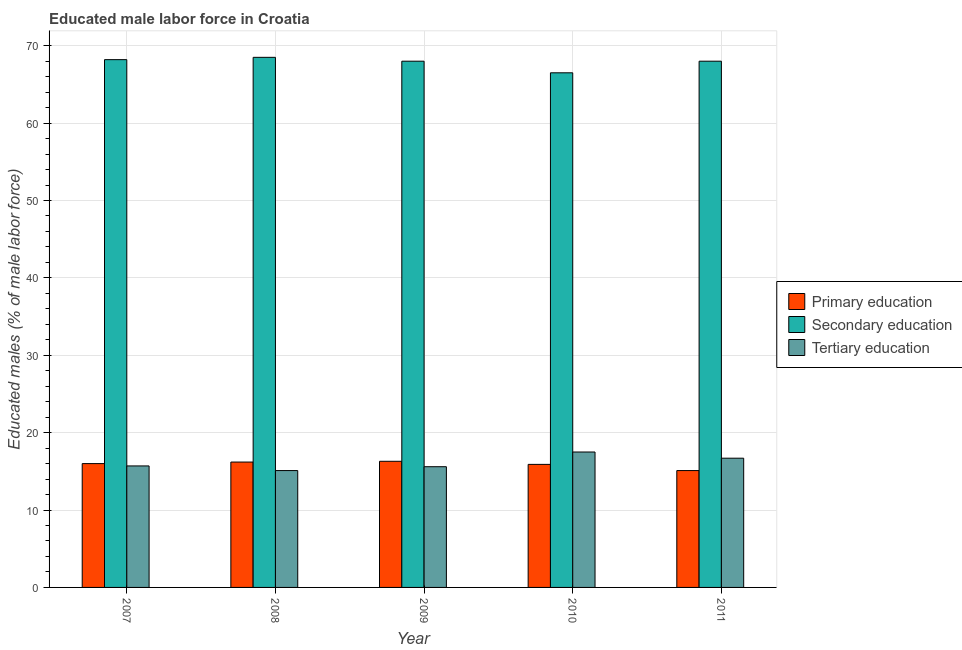How many groups of bars are there?
Offer a very short reply. 5. Are the number of bars on each tick of the X-axis equal?
Offer a terse response. Yes. What is the label of the 3rd group of bars from the left?
Offer a very short reply. 2009. What is the percentage of male labor force who received secondary education in 2007?
Make the answer very short. 68.2. Across all years, what is the maximum percentage of male labor force who received primary education?
Your response must be concise. 16.3. Across all years, what is the minimum percentage of male labor force who received primary education?
Your answer should be very brief. 15.1. In which year was the percentage of male labor force who received primary education minimum?
Keep it short and to the point. 2011. What is the total percentage of male labor force who received primary education in the graph?
Your response must be concise. 79.5. What is the difference between the percentage of male labor force who received tertiary education in 2008 and that in 2011?
Offer a very short reply. -1.6. What is the difference between the percentage of male labor force who received primary education in 2007 and the percentage of male labor force who received tertiary education in 2010?
Provide a succinct answer. 0.1. What is the average percentage of male labor force who received tertiary education per year?
Keep it short and to the point. 16.12. What is the ratio of the percentage of male labor force who received primary education in 2007 to that in 2008?
Provide a short and direct response. 0.99. What is the difference between the highest and the second highest percentage of male labor force who received tertiary education?
Keep it short and to the point. 0.8. What is the difference between the highest and the lowest percentage of male labor force who received secondary education?
Offer a very short reply. 2. Is the sum of the percentage of male labor force who received tertiary education in 2009 and 2011 greater than the maximum percentage of male labor force who received secondary education across all years?
Your answer should be very brief. Yes. What does the 2nd bar from the left in 2009 represents?
Provide a short and direct response. Secondary education. Is it the case that in every year, the sum of the percentage of male labor force who received primary education and percentage of male labor force who received secondary education is greater than the percentage of male labor force who received tertiary education?
Provide a short and direct response. Yes. How many bars are there?
Offer a very short reply. 15. Are all the bars in the graph horizontal?
Offer a very short reply. No. What is the difference between two consecutive major ticks on the Y-axis?
Keep it short and to the point. 10. Does the graph contain any zero values?
Your response must be concise. No. Where does the legend appear in the graph?
Your answer should be compact. Center right. How many legend labels are there?
Provide a short and direct response. 3. How are the legend labels stacked?
Provide a short and direct response. Vertical. What is the title of the graph?
Provide a short and direct response. Educated male labor force in Croatia. What is the label or title of the X-axis?
Ensure brevity in your answer.  Year. What is the label or title of the Y-axis?
Your response must be concise. Educated males (% of male labor force). What is the Educated males (% of male labor force) in Secondary education in 2007?
Your answer should be very brief. 68.2. What is the Educated males (% of male labor force) of Tertiary education in 2007?
Your response must be concise. 15.7. What is the Educated males (% of male labor force) in Primary education in 2008?
Offer a terse response. 16.2. What is the Educated males (% of male labor force) of Secondary education in 2008?
Offer a terse response. 68.5. What is the Educated males (% of male labor force) of Tertiary education in 2008?
Your answer should be compact. 15.1. What is the Educated males (% of male labor force) in Primary education in 2009?
Make the answer very short. 16.3. What is the Educated males (% of male labor force) in Tertiary education in 2009?
Ensure brevity in your answer.  15.6. What is the Educated males (% of male labor force) in Primary education in 2010?
Your response must be concise. 15.9. What is the Educated males (% of male labor force) of Secondary education in 2010?
Your response must be concise. 66.5. What is the Educated males (% of male labor force) in Tertiary education in 2010?
Your answer should be compact. 17.5. What is the Educated males (% of male labor force) in Primary education in 2011?
Offer a terse response. 15.1. What is the Educated males (% of male labor force) of Secondary education in 2011?
Offer a terse response. 68. What is the Educated males (% of male labor force) of Tertiary education in 2011?
Keep it short and to the point. 16.7. Across all years, what is the maximum Educated males (% of male labor force) in Primary education?
Offer a terse response. 16.3. Across all years, what is the maximum Educated males (% of male labor force) in Secondary education?
Provide a short and direct response. 68.5. Across all years, what is the minimum Educated males (% of male labor force) of Primary education?
Give a very brief answer. 15.1. Across all years, what is the minimum Educated males (% of male labor force) in Secondary education?
Your response must be concise. 66.5. Across all years, what is the minimum Educated males (% of male labor force) in Tertiary education?
Keep it short and to the point. 15.1. What is the total Educated males (% of male labor force) of Primary education in the graph?
Provide a short and direct response. 79.5. What is the total Educated males (% of male labor force) in Secondary education in the graph?
Give a very brief answer. 339.2. What is the total Educated males (% of male labor force) of Tertiary education in the graph?
Offer a terse response. 80.6. What is the difference between the Educated males (% of male labor force) in Secondary education in 2007 and that in 2008?
Ensure brevity in your answer.  -0.3. What is the difference between the Educated males (% of male labor force) in Primary education in 2007 and that in 2009?
Your response must be concise. -0.3. What is the difference between the Educated males (% of male labor force) in Secondary education in 2007 and that in 2009?
Keep it short and to the point. 0.2. What is the difference between the Educated males (% of male labor force) of Tertiary education in 2007 and that in 2009?
Provide a short and direct response. 0.1. What is the difference between the Educated males (% of male labor force) in Primary education in 2007 and that in 2010?
Your answer should be very brief. 0.1. What is the difference between the Educated males (% of male labor force) in Primary education in 2007 and that in 2011?
Make the answer very short. 0.9. What is the difference between the Educated males (% of male labor force) in Secondary education in 2008 and that in 2009?
Your answer should be very brief. 0.5. What is the difference between the Educated males (% of male labor force) of Primary education in 2008 and that in 2010?
Ensure brevity in your answer.  0.3. What is the difference between the Educated males (% of male labor force) of Secondary education in 2008 and that in 2010?
Your response must be concise. 2. What is the difference between the Educated males (% of male labor force) of Tertiary education in 2008 and that in 2010?
Your answer should be compact. -2.4. What is the difference between the Educated males (% of male labor force) of Primary education in 2008 and that in 2011?
Offer a very short reply. 1.1. What is the difference between the Educated males (% of male labor force) in Secondary education in 2009 and that in 2010?
Ensure brevity in your answer.  1.5. What is the difference between the Educated males (% of male labor force) in Secondary education in 2009 and that in 2011?
Your answer should be very brief. 0. What is the difference between the Educated males (% of male labor force) of Primary education in 2010 and that in 2011?
Provide a succinct answer. 0.8. What is the difference between the Educated males (% of male labor force) of Secondary education in 2010 and that in 2011?
Offer a terse response. -1.5. What is the difference between the Educated males (% of male labor force) in Primary education in 2007 and the Educated males (% of male labor force) in Secondary education in 2008?
Provide a short and direct response. -52.5. What is the difference between the Educated males (% of male labor force) in Secondary education in 2007 and the Educated males (% of male labor force) in Tertiary education in 2008?
Offer a very short reply. 53.1. What is the difference between the Educated males (% of male labor force) of Primary education in 2007 and the Educated males (% of male labor force) of Secondary education in 2009?
Your answer should be compact. -52. What is the difference between the Educated males (% of male labor force) in Secondary education in 2007 and the Educated males (% of male labor force) in Tertiary education in 2009?
Provide a short and direct response. 52.6. What is the difference between the Educated males (% of male labor force) in Primary education in 2007 and the Educated males (% of male labor force) in Secondary education in 2010?
Keep it short and to the point. -50.5. What is the difference between the Educated males (% of male labor force) of Primary education in 2007 and the Educated males (% of male labor force) of Tertiary education in 2010?
Provide a succinct answer. -1.5. What is the difference between the Educated males (% of male labor force) in Secondary education in 2007 and the Educated males (% of male labor force) in Tertiary education in 2010?
Offer a very short reply. 50.7. What is the difference between the Educated males (% of male labor force) in Primary education in 2007 and the Educated males (% of male labor force) in Secondary education in 2011?
Provide a succinct answer. -52. What is the difference between the Educated males (% of male labor force) of Secondary education in 2007 and the Educated males (% of male labor force) of Tertiary education in 2011?
Provide a succinct answer. 51.5. What is the difference between the Educated males (% of male labor force) of Primary education in 2008 and the Educated males (% of male labor force) of Secondary education in 2009?
Provide a succinct answer. -51.8. What is the difference between the Educated males (% of male labor force) of Primary education in 2008 and the Educated males (% of male labor force) of Tertiary education in 2009?
Your response must be concise. 0.6. What is the difference between the Educated males (% of male labor force) in Secondary education in 2008 and the Educated males (% of male labor force) in Tertiary education in 2009?
Your answer should be compact. 52.9. What is the difference between the Educated males (% of male labor force) in Primary education in 2008 and the Educated males (% of male labor force) in Secondary education in 2010?
Provide a short and direct response. -50.3. What is the difference between the Educated males (% of male labor force) of Primary education in 2008 and the Educated males (% of male labor force) of Tertiary education in 2010?
Your response must be concise. -1.3. What is the difference between the Educated males (% of male labor force) in Secondary education in 2008 and the Educated males (% of male labor force) in Tertiary education in 2010?
Your answer should be very brief. 51. What is the difference between the Educated males (% of male labor force) in Primary education in 2008 and the Educated males (% of male labor force) in Secondary education in 2011?
Offer a terse response. -51.8. What is the difference between the Educated males (% of male labor force) of Secondary education in 2008 and the Educated males (% of male labor force) of Tertiary education in 2011?
Provide a short and direct response. 51.8. What is the difference between the Educated males (% of male labor force) in Primary education in 2009 and the Educated males (% of male labor force) in Secondary education in 2010?
Your answer should be compact. -50.2. What is the difference between the Educated males (% of male labor force) of Secondary education in 2009 and the Educated males (% of male labor force) of Tertiary education in 2010?
Offer a terse response. 50.5. What is the difference between the Educated males (% of male labor force) in Primary education in 2009 and the Educated males (% of male labor force) in Secondary education in 2011?
Keep it short and to the point. -51.7. What is the difference between the Educated males (% of male labor force) of Primary education in 2009 and the Educated males (% of male labor force) of Tertiary education in 2011?
Your response must be concise. -0.4. What is the difference between the Educated males (% of male labor force) in Secondary education in 2009 and the Educated males (% of male labor force) in Tertiary education in 2011?
Offer a very short reply. 51.3. What is the difference between the Educated males (% of male labor force) in Primary education in 2010 and the Educated males (% of male labor force) in Secondary education in 2011?
Provide a succinct answer. -52.1. What is the difference between the Educated males (% of male labor force) in Primary education in 2010 and the Educated males (% of male labor force) in Tertiary education in 2011?
Keep it short and to the point. -0.8. What is the difference between the Educated males (% of male labor force) in Secondary education in 2010 and the Educated males (% of male labor force) in Tertiary education in 2011?
Your response must be concise. 49.8. What is the average Educated males (% of male labor force) of Primary education per year?
Provide a short and direct response. 15.9. What is the average Educated males (% of male labor force) in Secondary education per year?
Your response must be concise. 67.84. What is the average Educated males (% of male labor force) in Tertiary education per year?
Your response must be concise. 16.12. In the year 2007, what is the difference between the Educated males (% of male labor force) of Primary education and Educated males (% of male labor force) of Secondary education?
Your answer should be very brief. -52.2. In the year 2007, what is the difference between the Educated males (% of male labor force) in Secondary education and Educated males (% of male labor force) in Tertiary education?
Offer a very short reply. 52.5. In the year 2008, what is the difference between the Educated males (% of male labor force) in Primary education and Educated males (% of male labor force) in Secondary education?
Provide a succinct answer. -52.3. In the year 2008, what is the difference between the Educated males (% of male labor force) in Primary education and Educated males (% of male labor force) in Tertiary education?
Ensure brevity in your answer.  1.1. In the year 2008, what is the difference between the Educated males (% of male labor force) in Secondary education and Educated males (% of male labor force) in Tertiary education?
Offer a terse response. 53.4. In the year 2009, what is the difference between the Educated males (% of male labor force) of Primary education and Educated males (% of male labor force) of Secondary education?
Give a very brief answer. -51.7. In the year 2009, what is the difference between the Educated males (% of male labor force) in Primary education and Educated males (% of male labor force) in Tertiary education?
Keep it short and to the point. 0.7. In the year 2009, what is the difference between the Educated males (% of male labor force) of Secondary education and Educated males (% of male labor force) of Tertiary education?
Provide a short and direct response. 52.4. In the year 2010, what is the difference between the Educated males (% of male labor force) in Primary education and Educated males (% of male labor force) in Secondary education?
Offer a very short reply. -50.6. In the year 2011, what is the difference between the Educated males (% of male labor force) in Primary education and Educated males (% of male labor force) in Secondary education?
Your answer should be compact. -52.9. In the year 2011, what is the difference between the Educated males (% of male labor force) of Primary education and Educated males (% of male labor force) of Tertiary education?
Your answer should be compact. -1.6. In the year 2011, what is the difference between the Educated males (% of male labor force) in Secondary education and Educated males (% of male labor force) in Tertiary education?
Give a very brief answer. 51.3. What is the ratio of the Educated males (% of male labor force) of Secondary education in 2007 to that in 2008?
Your answer should be compact. 1. What is the ratio of the Educated males (% of male labor force) in Tertiary education in 2007 to that in 2008?
Your response must be concise. 1.04. What is the ratio of the Educated males (% of male labor force) in Primary education in 2007 to that in 2009?
Your answer should be very brief. 0.98. What is the ratio of the Educated males (% of male labor force) in Secondary education in 2007 to that in 2009?
Your answer should be compact. 1. What is the ratio of the Educated males (% of male labor force) of Tertiary education in 2007 to that in 2009?
Your answer should be compact. 1.01. What is the ratio of the Educated males (% of male labor force) in Primary education in 2007 to that in 2010?
Your answer should be compact. 1.01. What is the ratio of the Educated males (% of male labor force) of Secondary education in 2007 to that in 2010?
Keep it short and to the point. 1.03. What is the ratio of the Educated males (% of male labor force) in Tertiary education in 2007 to that in 2010?
Offer a terse response. 0.9. What is the ratio of the Educated males (% of male labor force) of Primary education in 2007 to that in 2011?
Offer a very short reply. 1.06. What is the ratio of the Educated males (% of male labor force) in Secondary education in 2007 to that in 2011?
Make the answer very short. 1. What is the ratio of the Educated males (% of male labor force) in Tertiary education in 2007 to that in 2011?
Provide a short and direct response. 0.94. What is the ratio of the Educated males (% of male labor force) of Primary education in 2008 to that in 2009?
Offer a terse response. 0.99. What is the ratio of the Educated males (% of male labor force) in Secondary education in 2008 to that in 2009?
Provide a short and direct response. 1.01. What is the ratio of the Educated males (% of male labor force) in Tertiary education in 2008 to that in 2009?
Ensure brevity in your answer.  0.97. What is the ratio of the Educated males (% of male labor force) in Primary education in 2008 to that in 2010?
Keep it short and to the point. 1.02. What is the ratio of the Educated males (% of male labor force) in Secondary education in 2008 to that in 2010?
Keep it short and to the point. 1.03. What is the ratio of the Educated males (% of male labor force) in Tertiary education in 2008 to that in 2010?
Give a very brief answer. 0.86. What is the ratio of the Educated males (% of male labor force) of Primary education in 2008 to that in 2011?
Keep it short and to the point. 1.07. What is the ratio of the Educated males (% of male labor force) in Secondary education in 2008 to that in 2011?
Provide a short and direct response. 1.01. What is the ratio of the Educated males (% of male labor force) in Tertiary education in 2008 to that in 2011?
Give a very brief answer. 0.9. What is the ratio of the Educated males (% of male labor force) in Primary education in 2009 to that in 2010?
Keep it short and to the point. 1.03. What is the ratio of the Educated males (% of male labor force) of Secondary education in 2009 to that in 2010?
Make the answer very short. 1.02. What is the ratio of the Educated males (% of male labor force) in Tertiary education in 2009 to that in 2010?
Keep it short and to the point. 0.89. What is the ratio of the Educated males (% of male labor force) of Primary education in 2009 to that in 2011?
Offer a terse response. 1.08. What is the ratio of the Educated males (% of male labor force) in Tertiary education in 2009 to that in 2011?
Your answer should be very brief. 0.93. What is the ratio of the Educated males (% of male labor force) in Primary education in 2010 to that in 2011?
Your answer should be compact. 1.05. What is the ratio of the Educated males (% of male labor force) of Secondary education in 2010 to that in 2011?
Ensure brevity in your answer.  0.98. What is the ratio of the Educated males (% of male labor force) of Tertiary education in 2010 to that in 2011?
Your response must be concise. 1.05. What is the difference between the highest and the second highest Educated males (% of male labor force) of Primary education?
Ensure brevity in your answer.  0.1. What is the difference between the highest and the second highest Educated males (% of male labor force) in Secondary education?
Offer a very short reply. 0.3. What is the difference between the highest and the second highest Educated males (% of male labor force) in Tertiary education?
Keep it short and to the point. 0.8. What is the difference between the highest and the lowest Educated males (% of male labor force) in Primary education?
Provide a succinct answer. 1.2. What is the difference between the highest and the lowest Educated males (% of male labor force) in Secondary education?
Your answer should be compact. 2. 